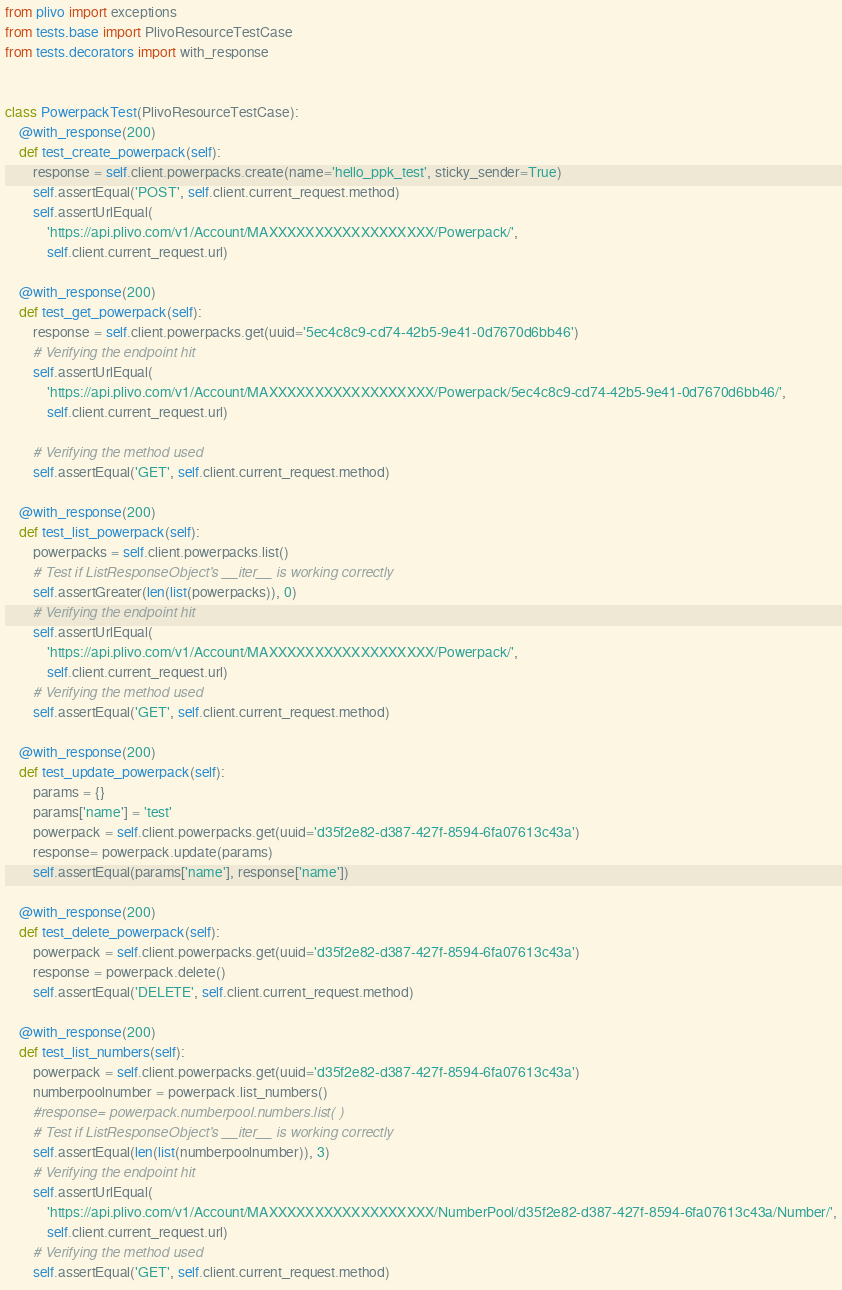Convert code to text. <code><loc_0><loc_0><loc_500><loc_500><_Python_>from plivo import exceptions
from tests.base import PlivoResourceTestCase
from tests.decorators import with_response


class PowerpackTest(PlivoResourceTestCase):
    @with_response(200)
    def test_create_powerpack(self):
        response = self.client.powerpacks.create(name='hello_ppk_test', sticky_sender=True)
        self.assertEqual('POST', self.client.current_request.method)
        self.assertUrlEqual(
            'https://api.plivo.com/v1/Account/MAXXXXXXXXXXXXXXXXXX/Powerpack/',
            self.client.current_request.url)

    @with_response(200)
    def test_get_powerpack(self):
        response = self.client.powerpacks.get(uuid='5ec4c8c9-cd74-42b5-9e41-0d7670d6bb46')
        # Verifying the endpoint hit
        self.assertUrlEqual(
            'https://api.plivo.com/v1/Account/MAXXXXXXXXXXXXXXXXXX/Powerpack/5ec4c8c9-cd74-42b5-9e41-0d7670d6bb46/',
            self.client.current_request.url)

        # Verifying the method used
        self.assertEqual('GET', self.client.current_request.method)

    @with_response(200)
    def test_list_powerpack(self):
        powerpacks = self.client.powerpacks.list()
        # Test if ListResponseObject's __iter__ is working correctly
        self.assertGreater(len(list(powerpacks)), 0)
        # Verifying the endpoint hit
        self.assertUrlEqual(
            'https://api.plivo.com/v1/Account/MAXXXXXXXXXXXXXXXXXX/Powerpack/',
            self.client.current_request.url)
        # Verifying the method used
        self.assertEqual('GET', self.client.current_request.method)

    @with_response(200)
    def test_update_powerpack(self):
        params = {}
        params['name'] = 'test'
        powerpack = self.client.powerpacks.get(uuid='d35f2e82-d387-427f-8594-6fa07613c43a')
        response= powerpack.update(params)
        self.assertEqual(params['name'], response['name'])
    
    @with_response(200)
    def test_delete_powerpack(self):
        powerpack = self.client.powerpacks.get(uuid='d35f2e82-d387-427f-8594-6fa07613c43a')
        response = powerpack.delete()
        self.assertEqual('DELETE', self.client.current_request.method)

    @with_response(200)
    def test_list_numbers(self):
        powerpack = self.client.powerpacks.get(uuid='d35f2e82-d387-427f-8594-6fa07613c43a')
        numberpoolnumber = powerpack.list_numbers()
        #response= powerpack.numberpool.numbers.list( )
        # Test if ListResponseObject's __iter__ is working correctly
        self.assertEqual(len(list(numberpoolnumber)), 3)
        # Verifying the endpoint hit
        self.assertUrlEqual(
            'https://api.plivo.com/v1/Account/MAXXXXXXXXXXXXXXXXXX/NumberPool/d35f2e82-d387-427f-8594-6fa07613c43a/Number/',
            self.client.current_request.url)
        # Verifying the method used
        self.assertEqual('GET', self.client.current_request.method)
</code> 